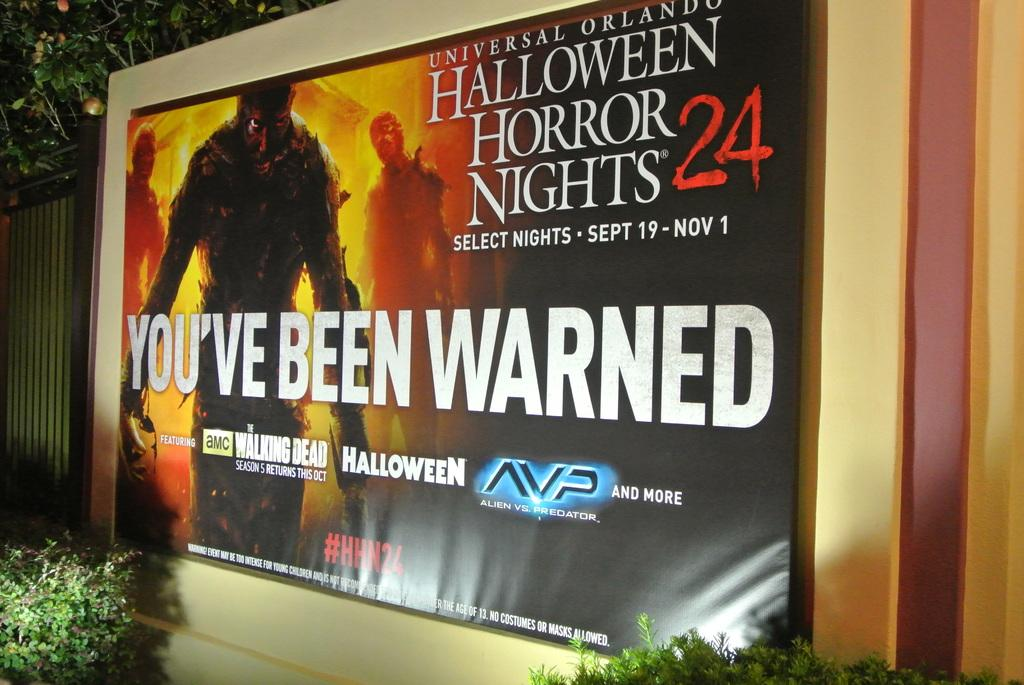<image>
Offer a succinct explanation of the picture presented. Halloween Horror Nights 24 selected nights from September through November sign with You've Been Warned in large white letters. 